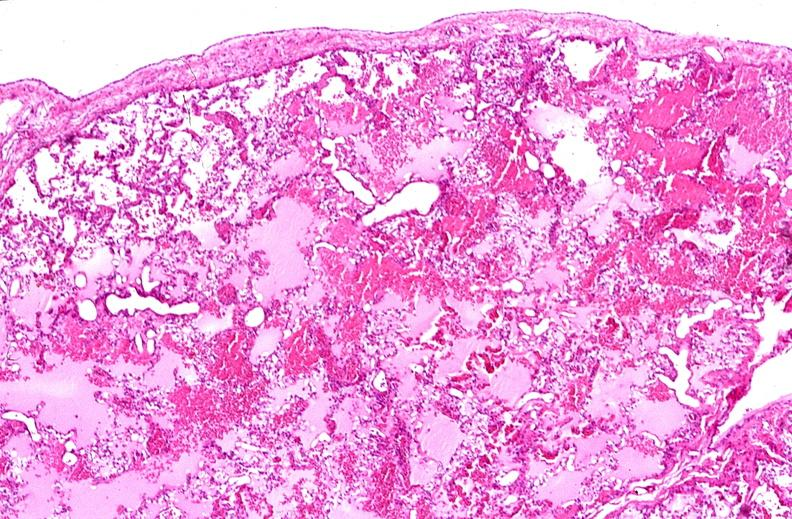where is this?
Answer the question using a single word or phrase. Lung 